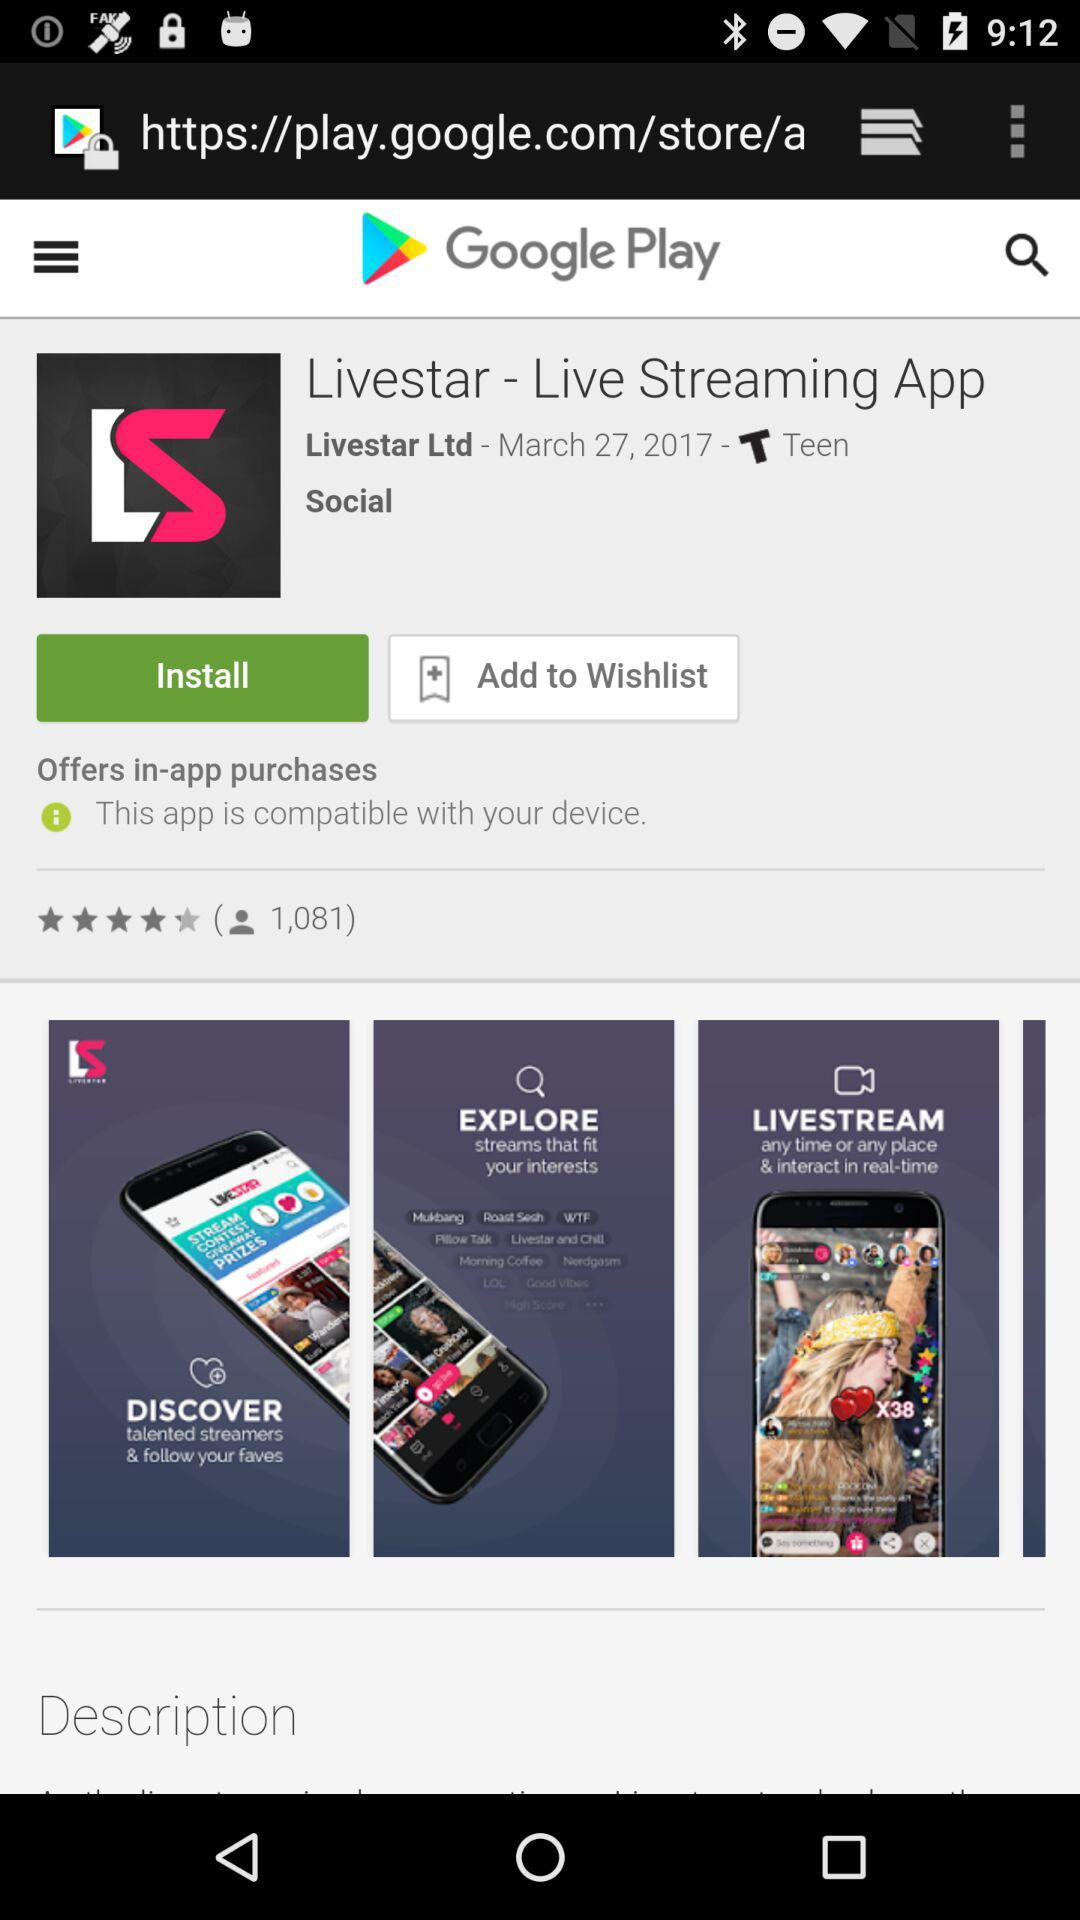What's the total number of users who have rated the app? The total number of users who have rated the app is 1,081. 